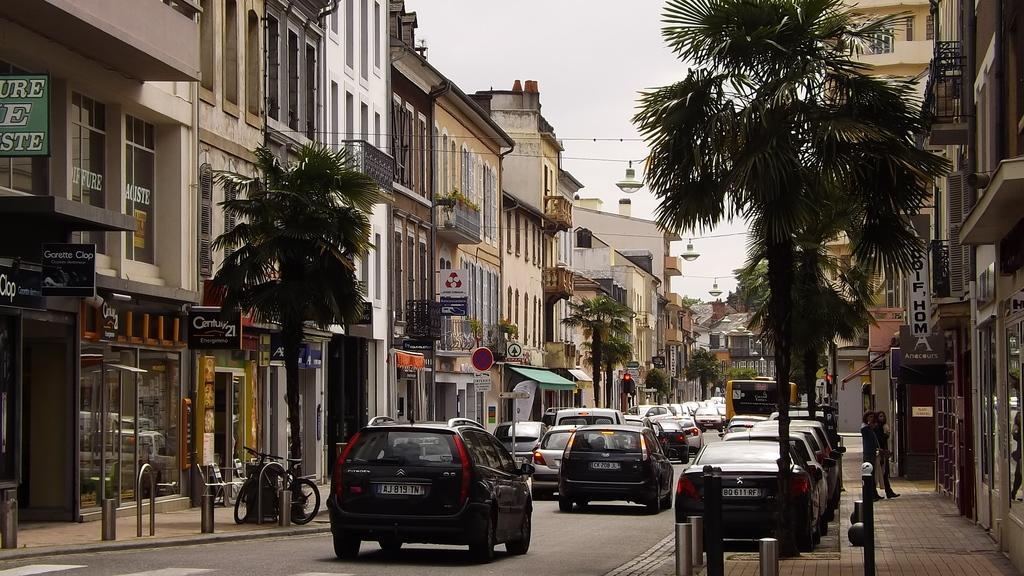In one or two sentences, can you explain what this image depicts? In the center of the image there are cars on the road. On both right and left side of the image there are buildings, trees, traffic signals, sign boards, poles. On the right side of the image there are two people walking on the pavement. In the background of the image there is sky. 